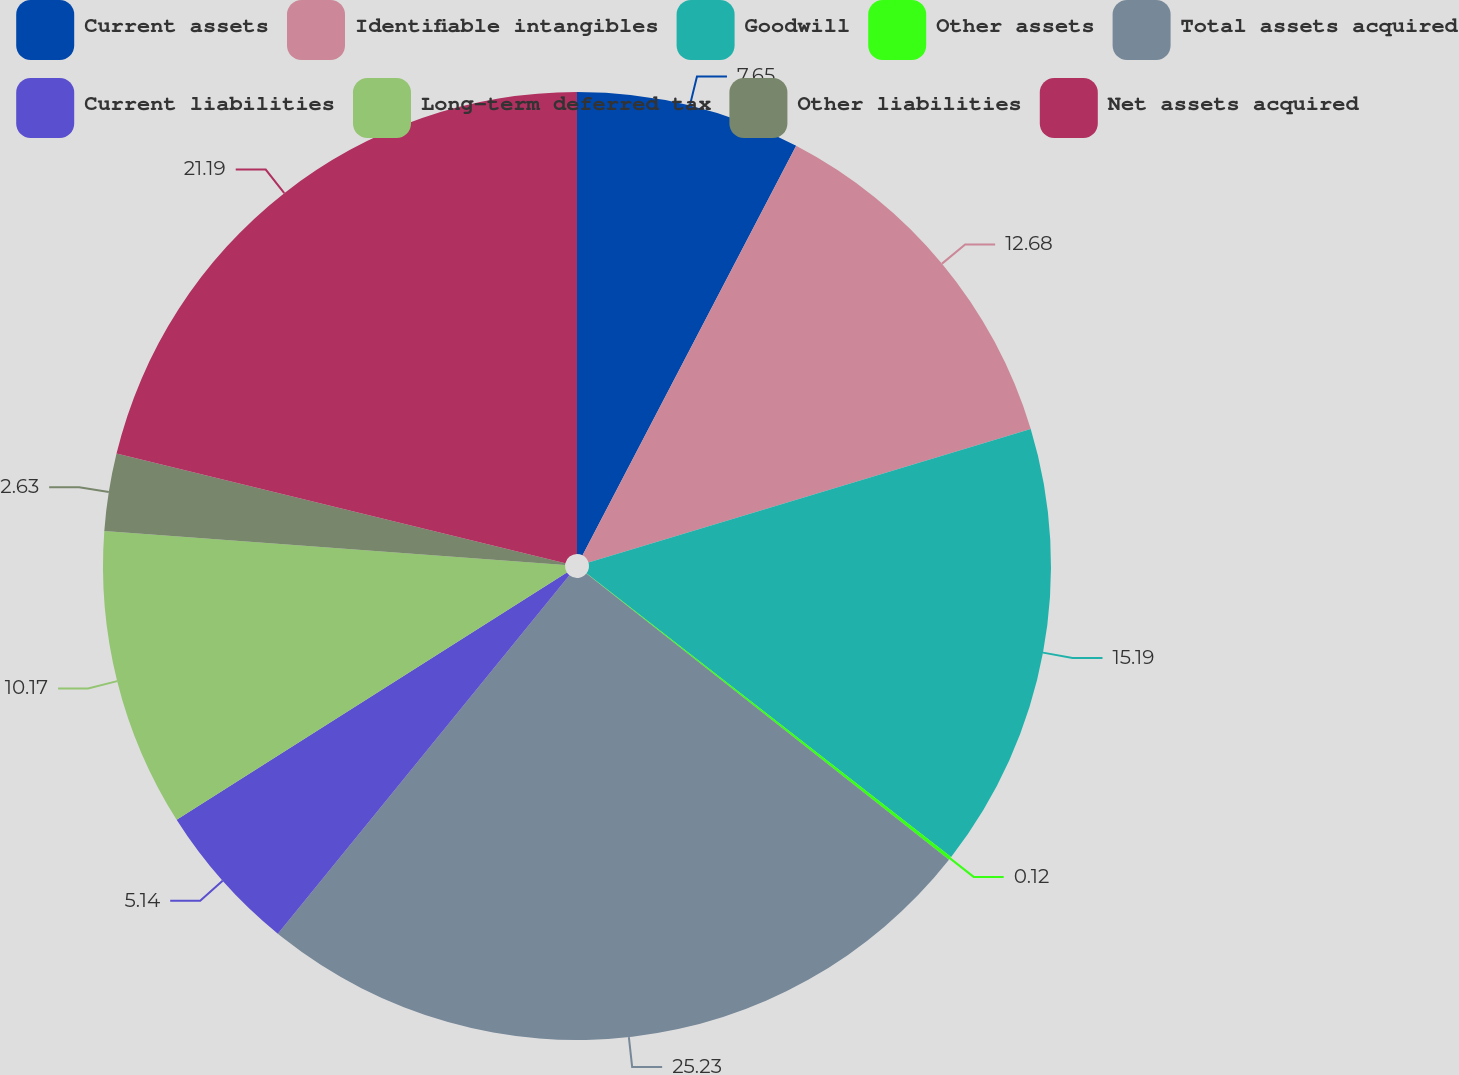<chart> <loc_0><loc_0><loc_500><loc_500><pie_chart><fcel>Current assets<fcel>Identifiable intangibles<fcel>Goodwill<fcel>Other assets<fcel>Total assets acquired<fcel>Current liabilities<fcel>Long-term deferred tax<fcel>Other liabilities<fcel>Net assets acquired<nl><fcel>7.65%<fcel>12.68%<fcel>15.19%<fcel>0.12%<fcel>25.23%<fcel>5.14%<fcel>10.17%<fcel>2.63%<fcel>21.19%<nl></chart> 